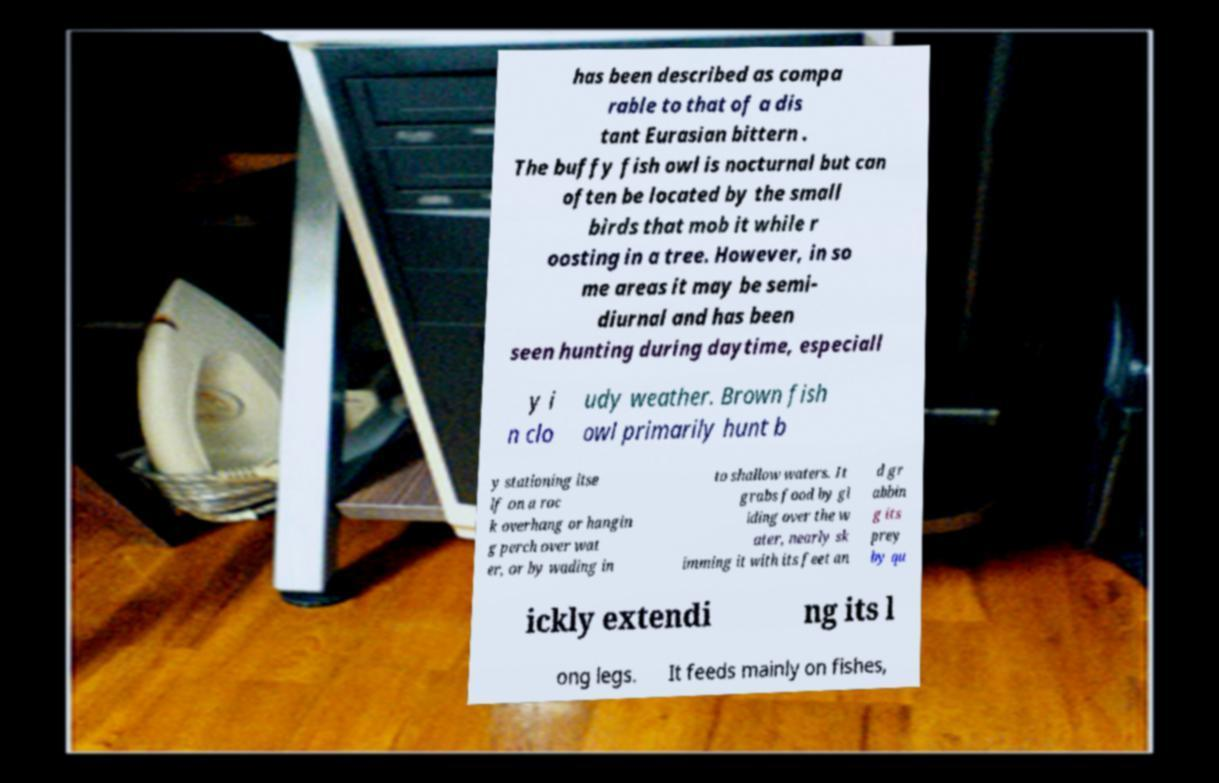Can you read and provide the text displayed in the image?This photo seems to have some interesting text. Can you extract and type it out for me? has been described as compa rable to that of a dis tant Eurasian bittern . The buffy fish owl is nocturnal but can often be located by the small birds that mob it while r oosting in a tree. However, in so me areas it may be semi- diurnal and has been seen hunting during daytime, especiall y i n clo udy weather. Brown fish owl primarily hunt b y stationing itse lf on a roc k overhang or hangin g perch over wat er, or by wading in to shallow waters. It grabs food by gl iding over the w ater, nearly sk imming it with its feet an d gr abbin g its prey by qu ickly extendi ng its l ong legs. It feeds mainly on fishes, 